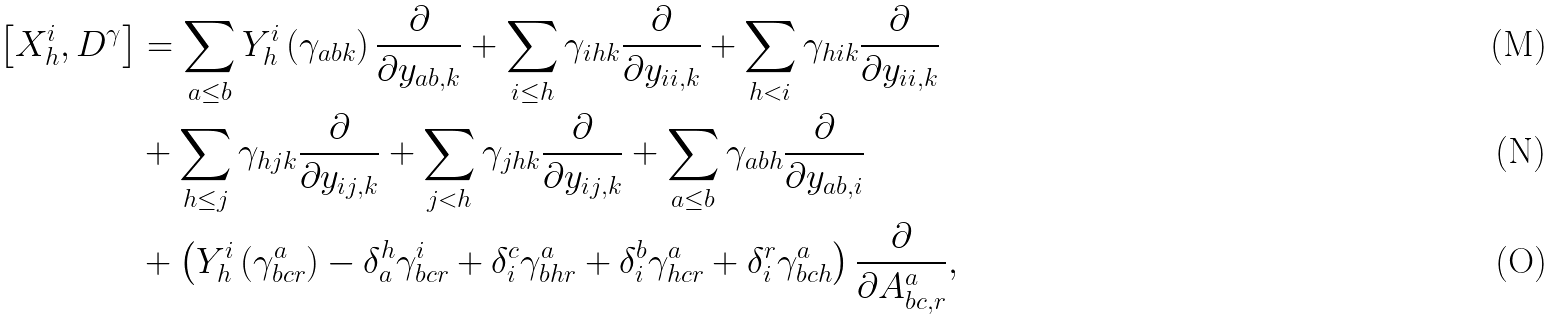Convert formula to latex. <formula><loc_0><loc_0><loc_500><loc_500>\left [ X _ { h } ^ { i } , D ^ { \gamma } \right ] & = \sum _ { a \leq b } Y _ { h } ^ { i } \left ( \gamma _ { a b k } \right ) \frac { \partial } { \partial y _ { a b , k } } + \sum _ { i \leq h } \gamma _ { i h k } \frac { \partial } { \partial y _ { i i , k } } + \sum _ { h < i } \gamma _ { h i k } \frac { \partial } { \partial y _ { i i , k } } \\ & + \sum _ { h \leq j } \gamma _ { h j k } \frac { \partial } { \partial y _ { i j , k } } + \sum _ { j < h } \gamma _ { j h k } \frac { \partial } { \partial y _ { i j , k } } + \sum _ { a \leq b } \gamma _ { a b h } \frac { \partial } { \partial y _ { a b , i } } \\ & + \left ( Y _ { h } ^ { i } \left ( \gamma _ { b c r } ^ { a } \right ) - \delta _ { a } ^ { h } \gamma _ { b c r } ^ { i } + \delta _ { i } ^ { c } \gamma _ { b h r } ^ { a } + \delta _ { i } ^ { b } \gamma _ { h c r } ^ { a } + \delta _ { i } ^ { r } \gamma _ { b c h } ^ { a } \right ) \frac { \partial } { \partial A _ { b c , r } ^ { a } } ,</formula> 